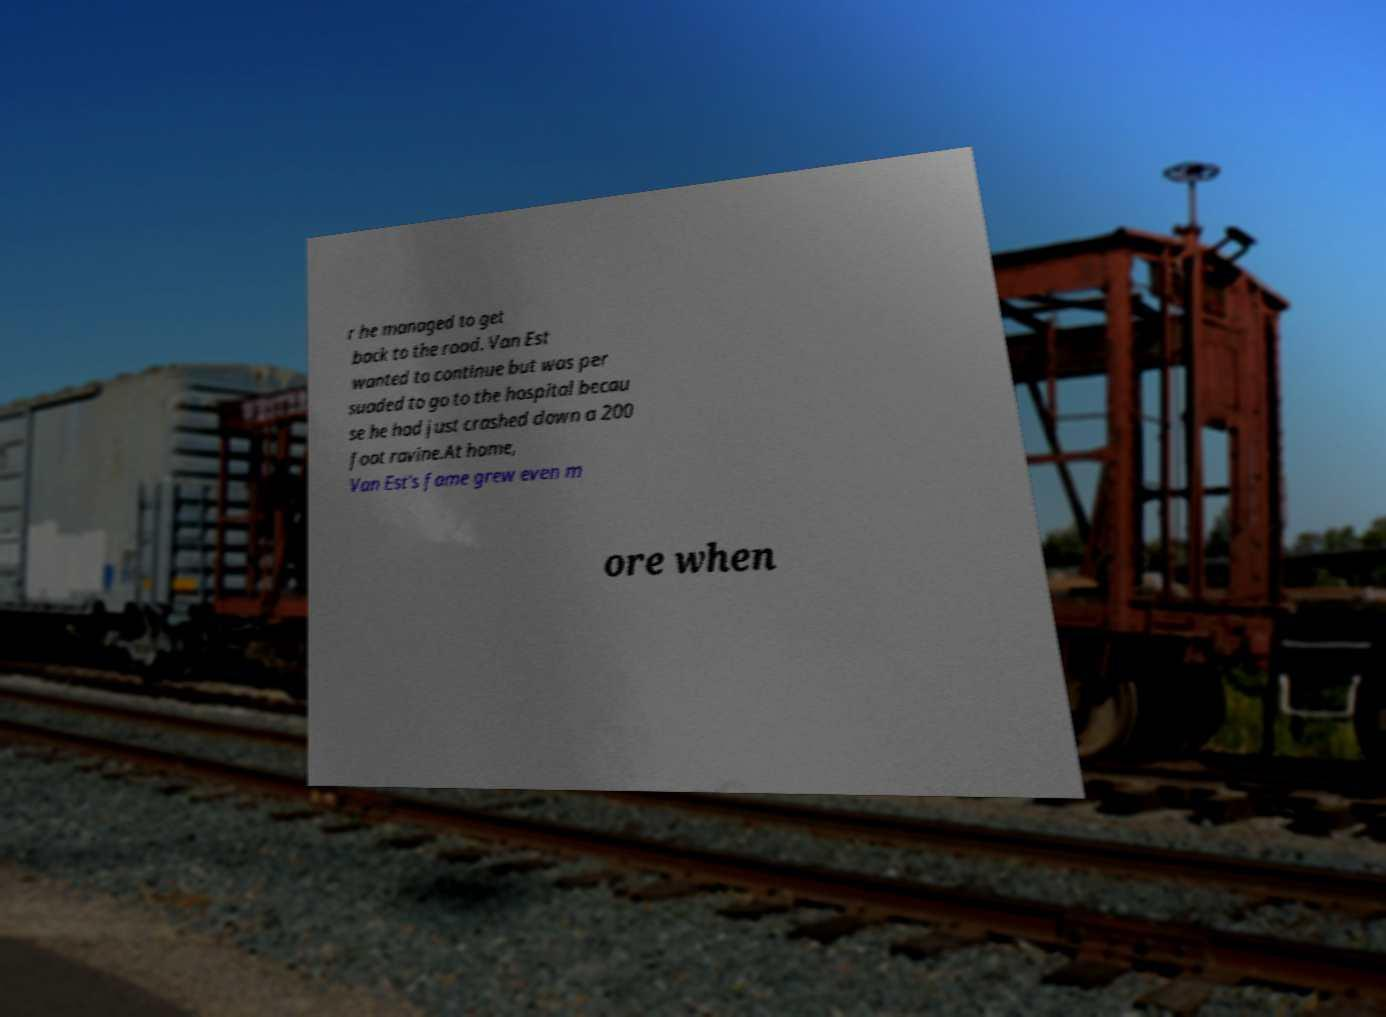Could you assist in decoding the text presented in this image and type it out clearly? r he managed to get back to the road. Van Est wanted to continue but was per suaded to go to the hospital becau se he had just crashed down a 200 foot ravine.At home, Van Est's fame grew even m ore when 